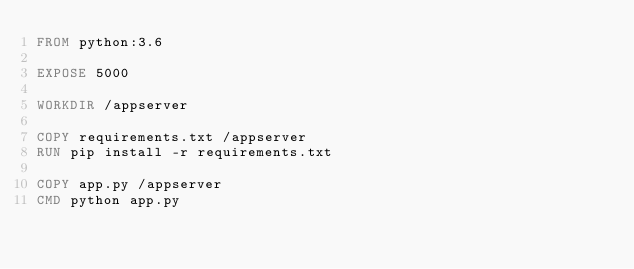Convert code to text. <code><loc_0><loc_0><loc_500><loc_500><_Dockerfile_>FROM python:3.6

EXPOSE 5000

WORKDIR /appserver

COPY requirements.txt /appserver
RUN pip install -r requirements.txt

COPY app.py /appserver
CMD python app.py
</code> 